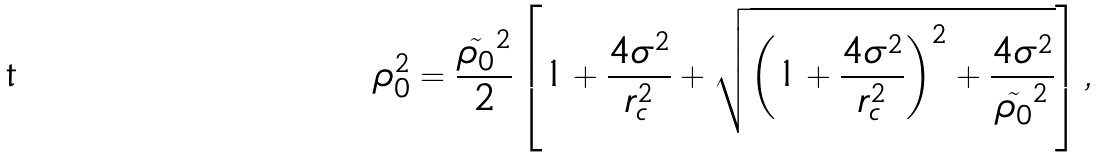<formula> <loc_0><loc_0><loc_500><loc_500>\rho _ { 0 } ^ { 2 } = \frac { \tilde { \rho _ { 0 } } ^ { 2 } } { 2 } \left [ 1 + \frac { 4 \sigma ^ { 2 } } { r _ { c } ^ { 2 } } + \sqrt { \left ( 1 + \frac { 4 \sigma ^ { 2 } } { r _ { c } ^ { 2 } } \right ) ^ { 2 } + \frac { 4 \sigma ^ { 2 } } { \tilde { \rho _ { 0 } } ^ { 2 } } } \right ] ,</formula> 